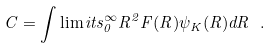<formula> <loc_0><loc_0><loc_500><loc_500>C = \int \lim i t s ^ { \infty } _ { 0 } R ^ { 2 } F ( R ) \psi _ { K } ( R ) d R \ .</formula> 